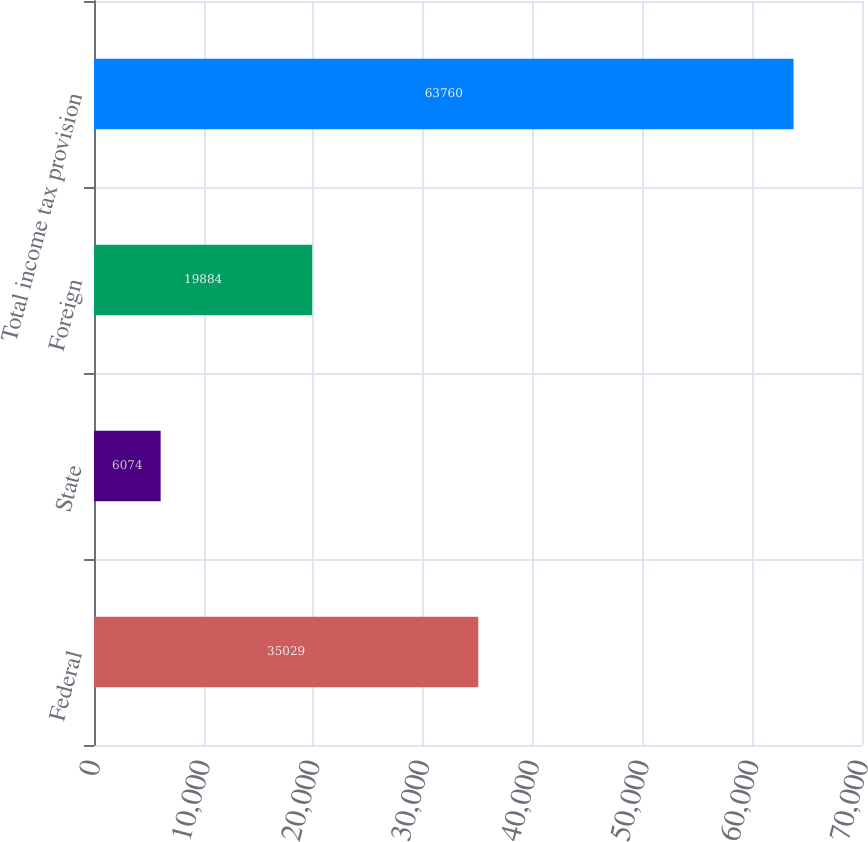Convert chart to OTSL. <chart><loc_0><loc_0><loc_500><loc_500><bar_chart><fcel>Federal<fcel>State<fcel>Foreign<fcel>Total income tax provision<nl><fcel>35029<fcel>6074<fcel>19884<fcel>63760<nl></chart> 